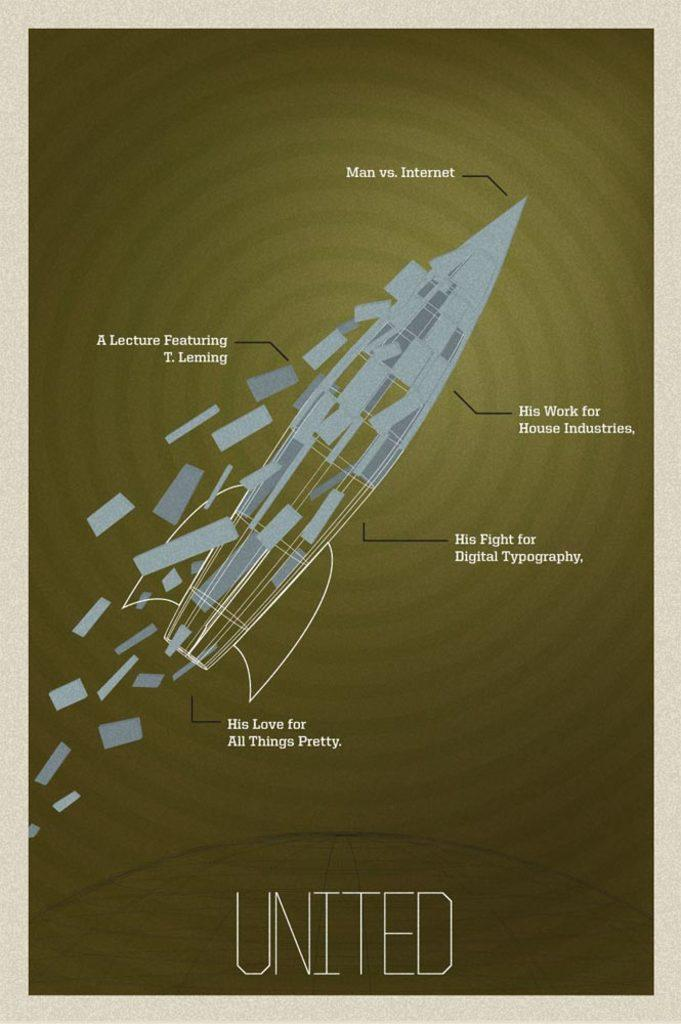<image>
Create a compact narrative representing the image presented. A poster is advertising a lecture featuring T. Leming. 